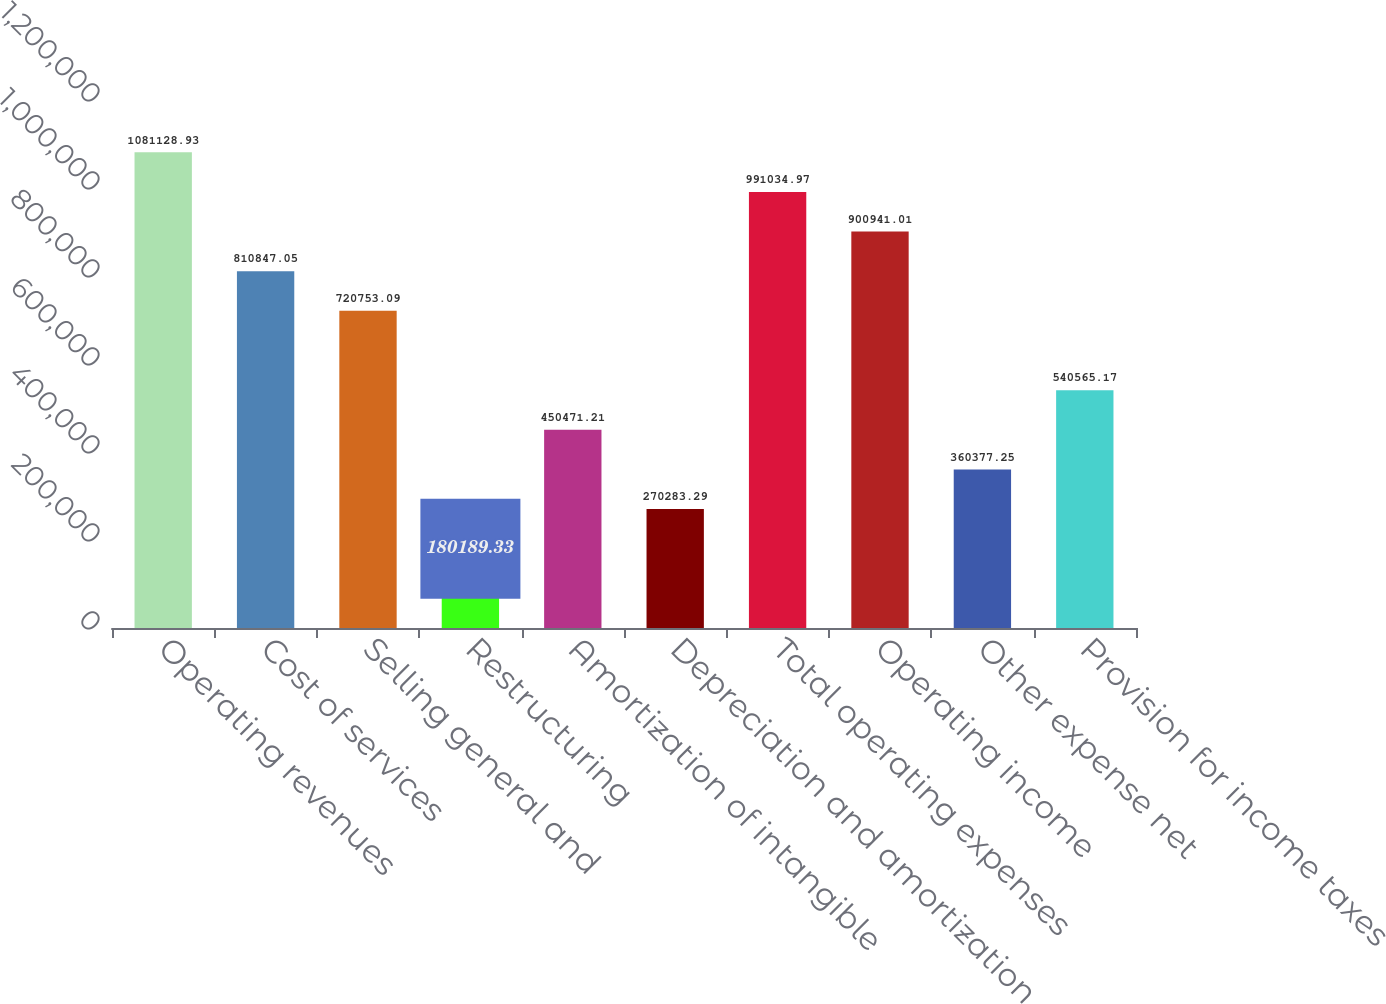Convert chart. <chart><loc_0><loc_0><loc_500><loc_500><bar_chart><fcel>Operating revenues<fcel>Cost of services<fcel>Selling general and<fcel>Restructuring<fcel>Amortization of intangible<fcel>Depreciation and amortization<fcel>Total operating expenses<fcel>Operating income<fcel>Other expense net<fcel>Provision for income taxes<nl><fcel>1.08113e+06<fcel>810847<fcel>720753<fcel>180189<fcel>450471<fcel>270283<fcel>991035<fcel>900941<fcel>360377<fcel>540565<nl></chart> 